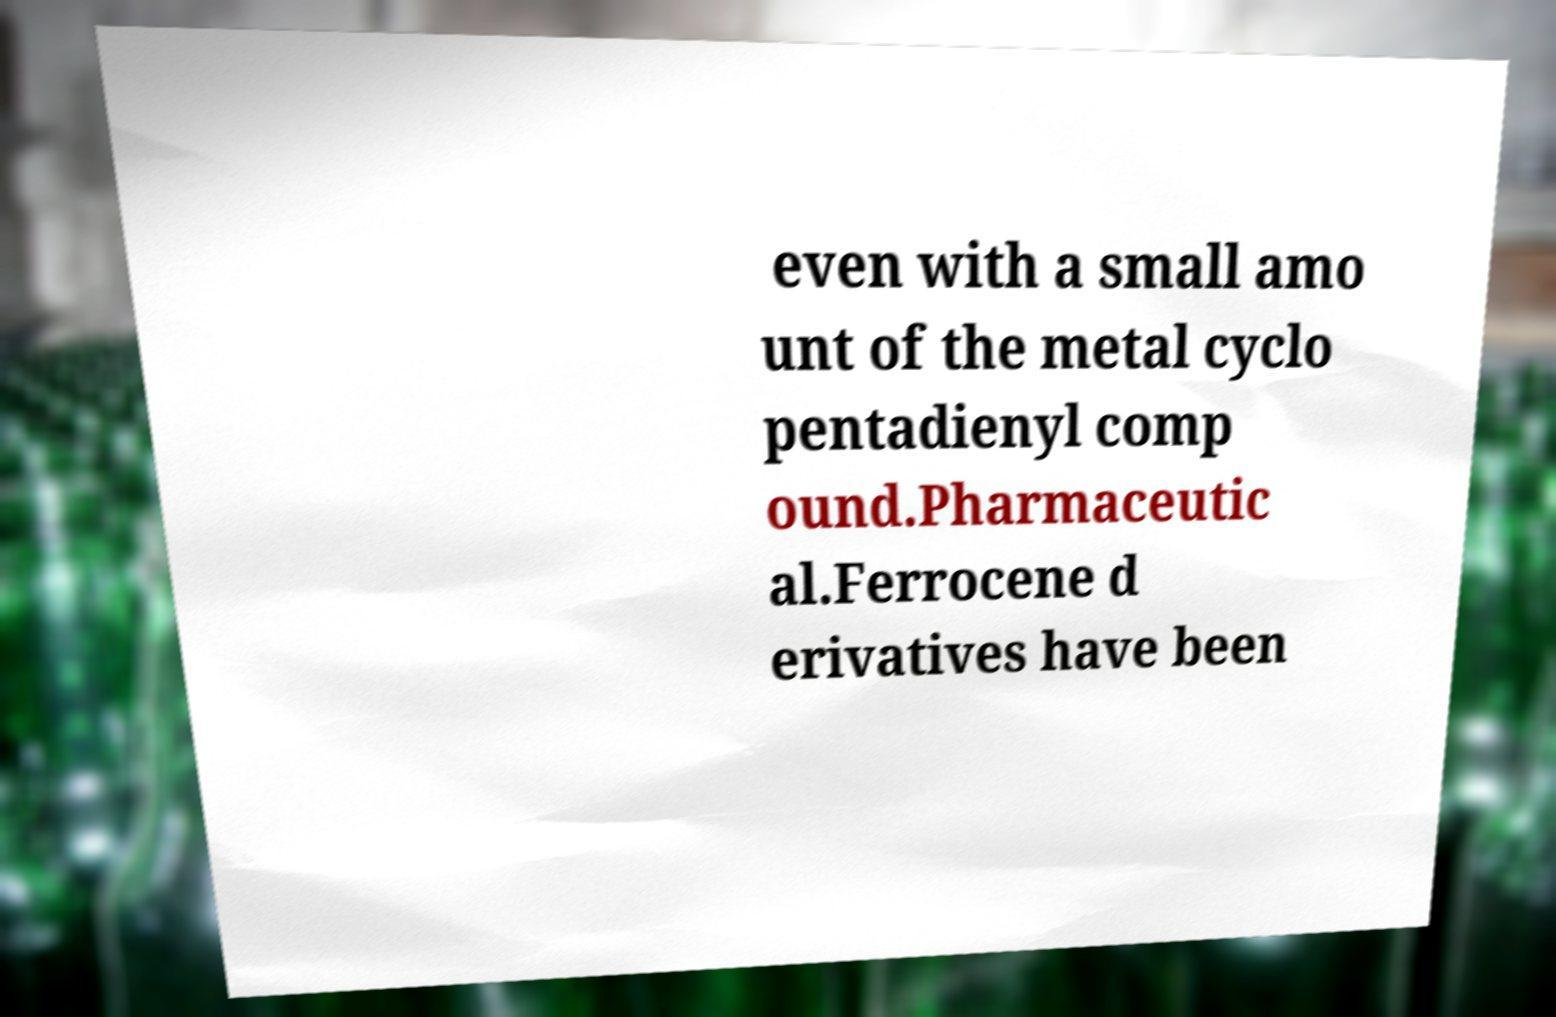Please read and relay the text visible in this image. What does it say? even with a small amo unt of the metal cyclo pentadienyl comp ound.Pharmaceutic al.Ferrocene d erivatives have been 